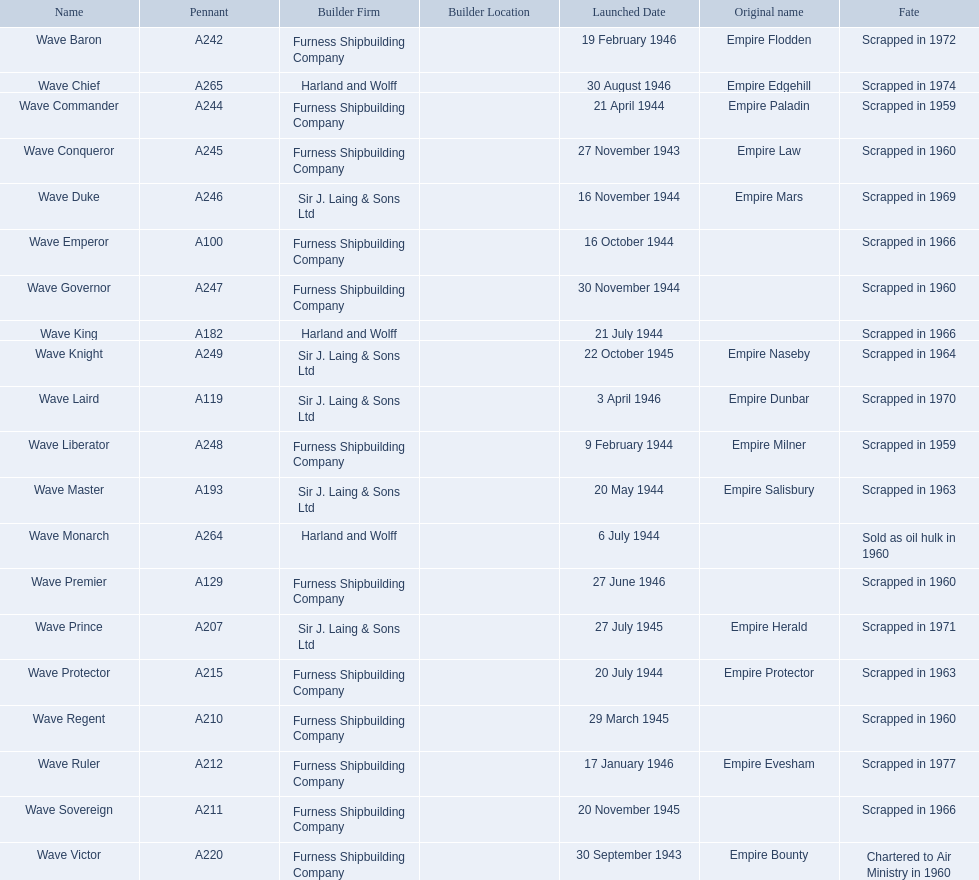What year was the wave victor launched? 30 September 1943. What other ship was launched in 1943? Wave Conqueror. 